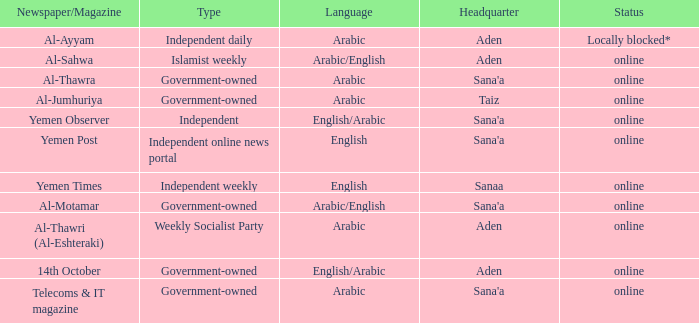When the language is english and the type is an independent online news portal, where is the headquarters located? Sana'a. 